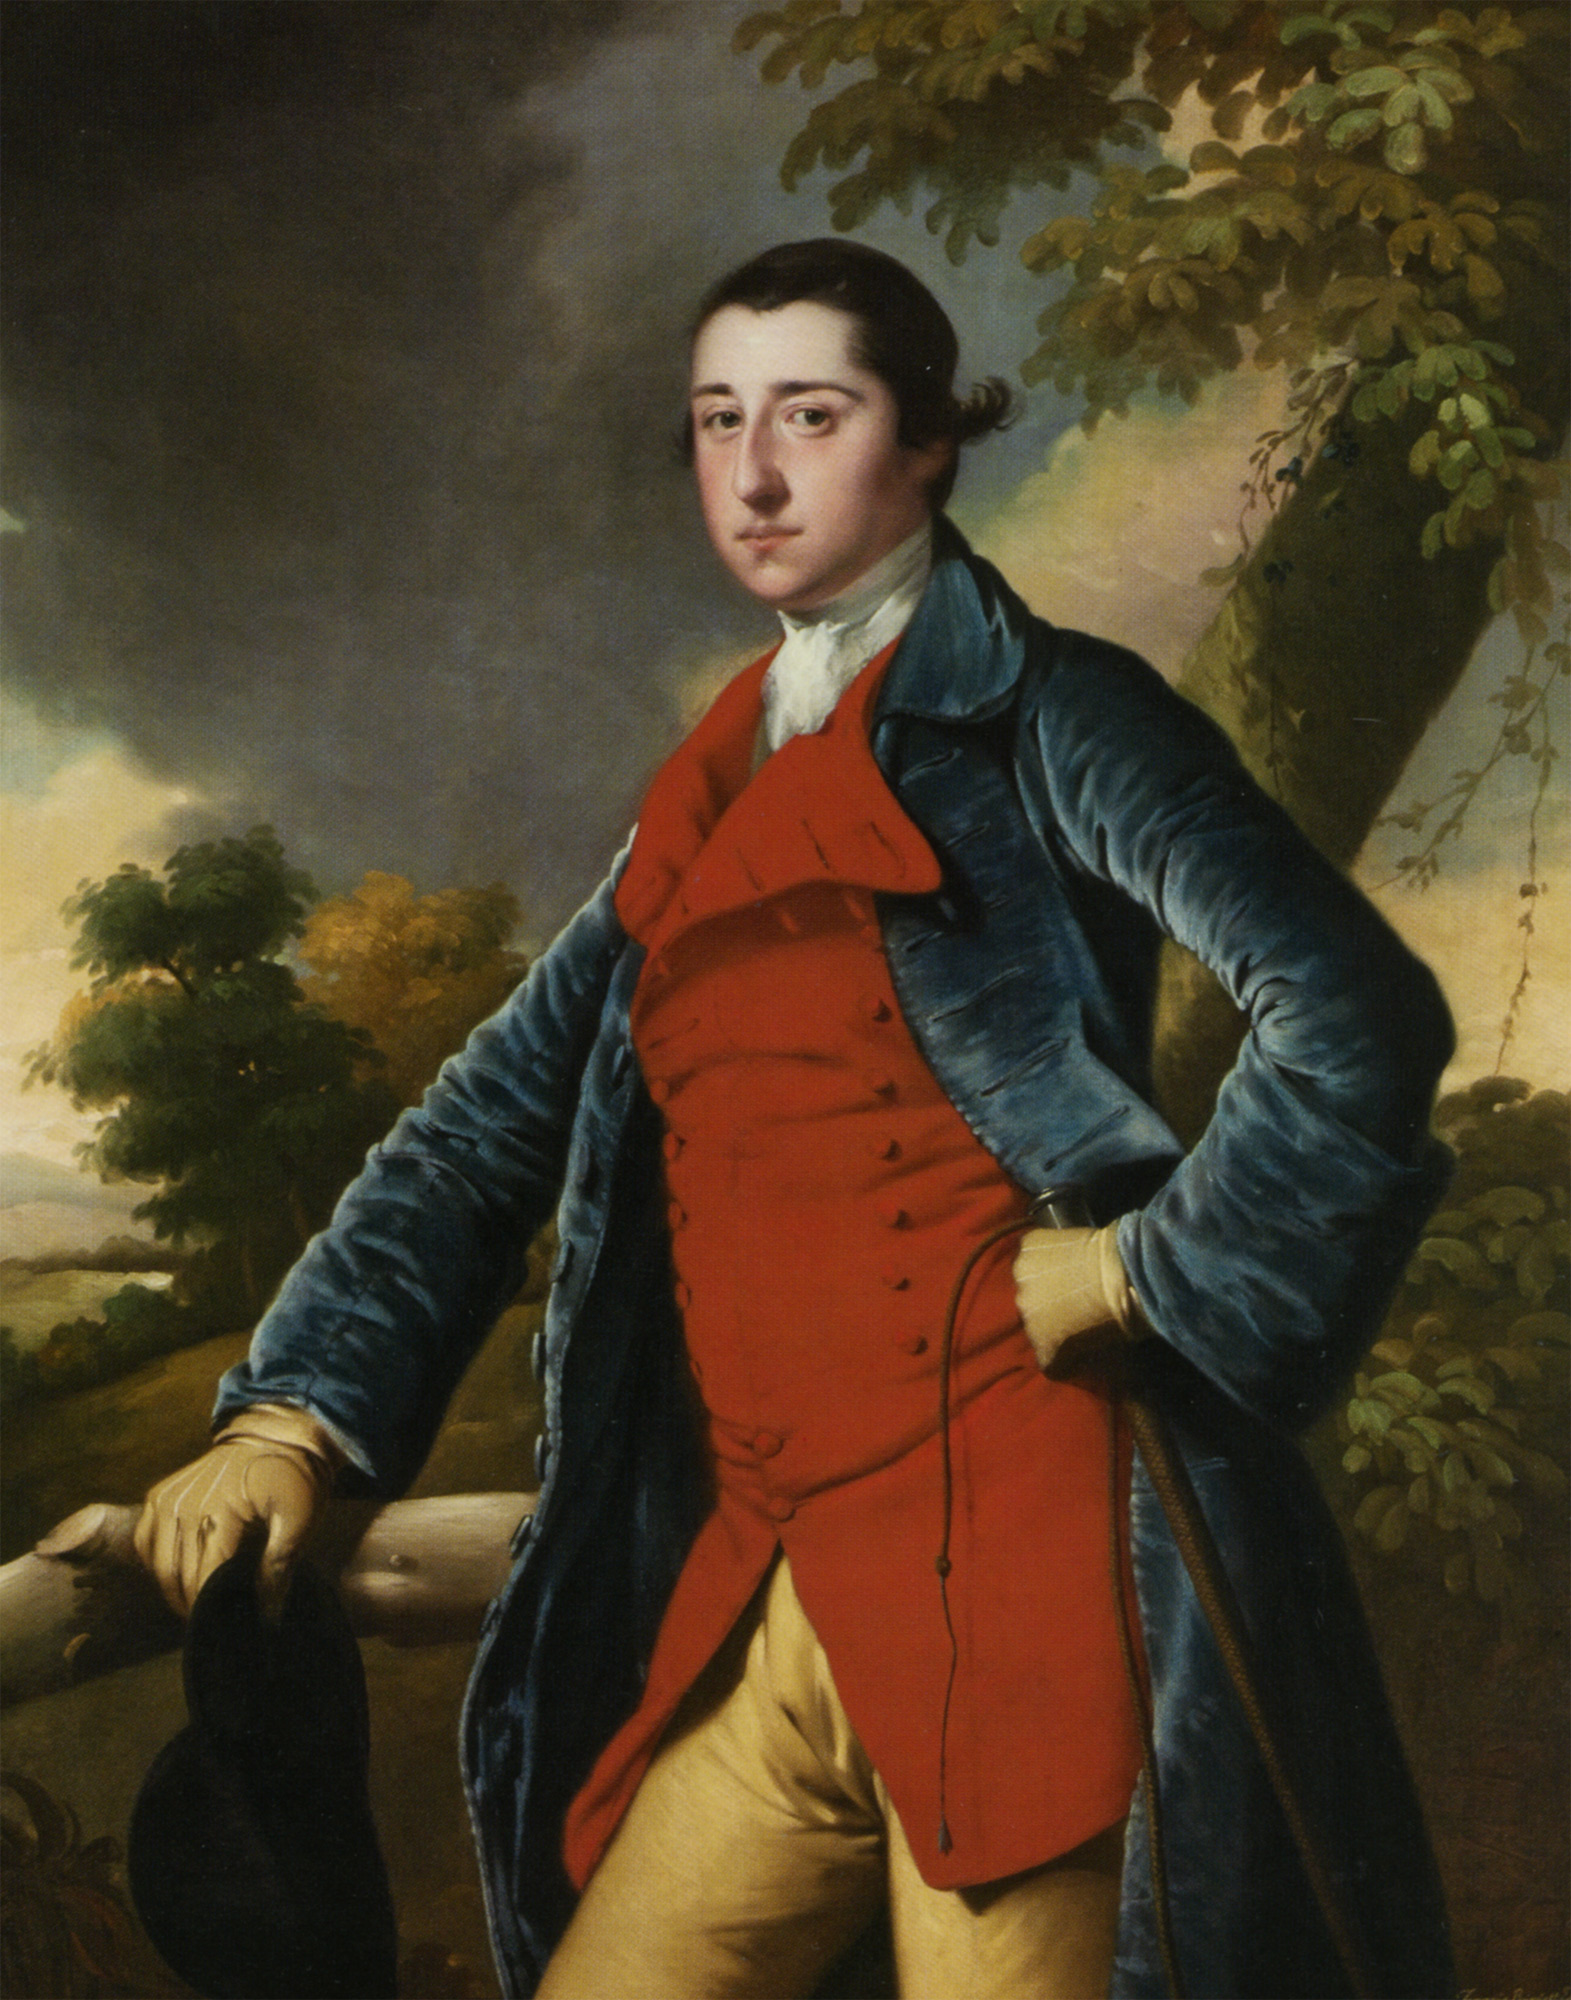Analyze the image in a comprehensive and detailed manner. The image features a young man dressed in the 18th-century attire, standing against a backdrop that consists of a sprawling landscape filled with trees and a cloud-filled sky, adding a sense of depth to the scene. The man is elegant, clad in a striking blue coat with gold buttons, a vivid red waistcoat, and yellow breeches. He holds a black hat in his left hand, a common accessory of that era. The painting appears to be executed in the Rococo style, known for its delicate and elegant aesthetics, utilizing curving, organic forms in the decoration. The depiction of the man in a grand and expansive landscape suggests the Grand Manner style, a genre that idealizes its subjects, often in majestic and imposing surroundings. 